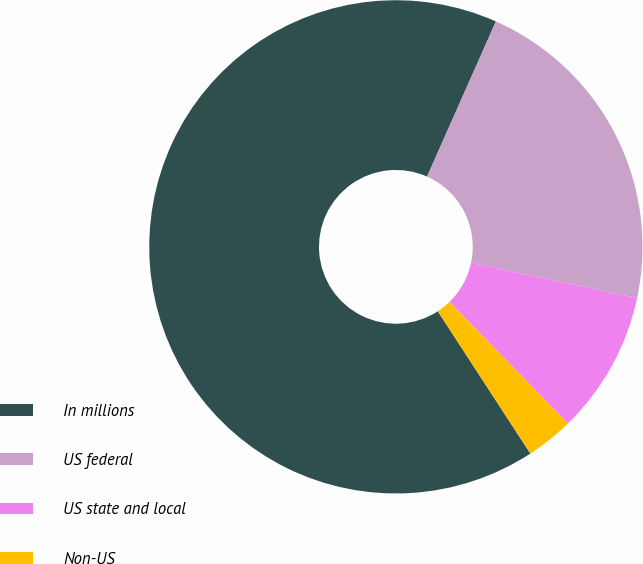Convert chart to OTSL. <chart><loc_0><loc_0><loc_500><loc_500><pie_chart><fcel>In millions<fcel>US federal<fcel>US state and local<fcel>Non-US<nl><fcel>65.83%<fcel>21.68%<fcel>9.38%<fcel>3.11%<nl></chart> 